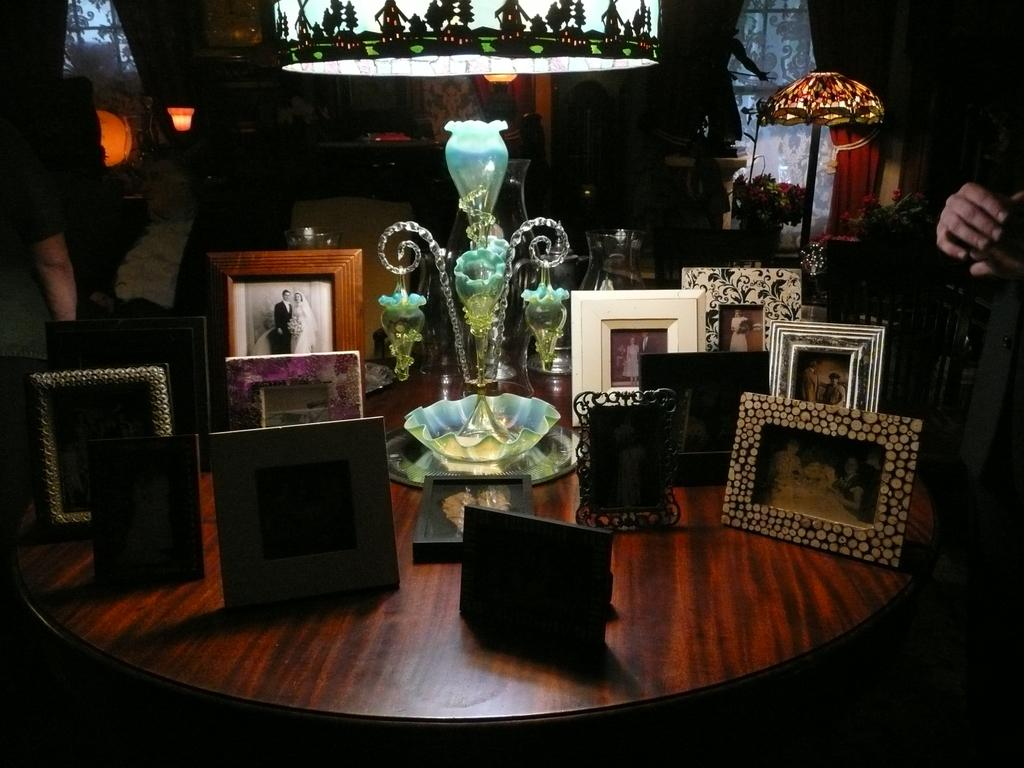What is the main object in the center of the image? There is a table in the middle of the image. What is placed on the table? There are multiple photo frames and a lamp on the table. Can you describe the background of the image? There is a person, a light source, and a window in the background of the image. What color is the crayon used by the person in the image? There is no crayon present in the image. Can you describe the swimming technique of the person in the image? There is no person swimming in the image; the person is in the background, not engaging in any swimming activity. 